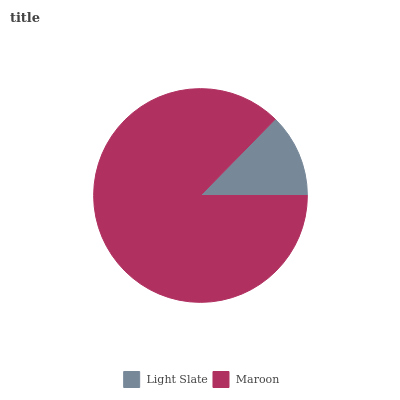Is Light Slate the minimum?
Answer yes or no. Yes. Is Maroon the maximum?
Answer yes or no. Yes. Is Maroon the minimum?
Answer yes or no. No. Is Maroon greater than Light Slate?
Answer yes or no. Yes. Is Light Slate less than Maroon?
Answer yes or no. Yes. Is Light Slate greater than Maroon?
Answer yes or no. No. Is Maroon less than Light Slate?
Answer yes or no. No. Is Maroon the high median?
Answer yes or no. Yes. Is Light Slate the low median?
Answer yes or no. Yes. Is Light Slate the high median?
Answer yes or no. No. Is Maroon the low median?
Answer yes or no. No. 